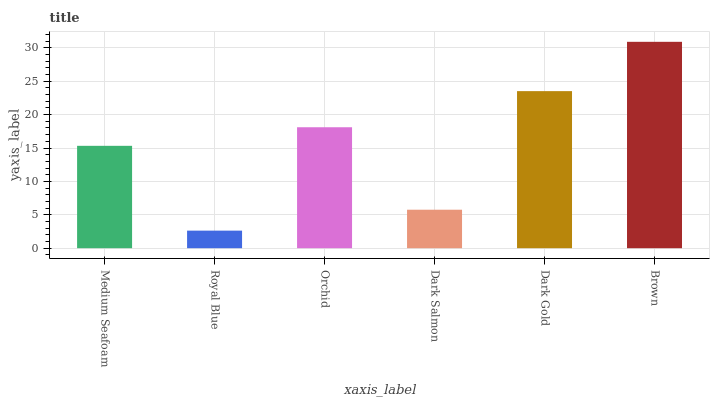Is Royal Blue the minimum?
Answer yes or no. Yes. Is Brown the maximum?
Answer yes or no. Yes. Is Orchid the minimum?
Answer yes or no. No. Is Orchid the maximum?
Answer yes or no. No. Is Orchid greater than Royal Blue?
Answer yes or no. Yes. Is Royal Blue less than Orchid?
Answer yes or no. Yes. Is Royal Blue greater than Orchid?
Answer yes or no. No. Is Orchid less than Royal Blue?
Answer yes or no. No. Is Orchid the high median?
Answer yes or no. Yes. Is Medium Seafoam the low median?
Answer yes or no. Yes. Is Dark Gold the high median?
Answer yes or no. No. Is Dark Gold the low median?
Answer yes or no. No. 